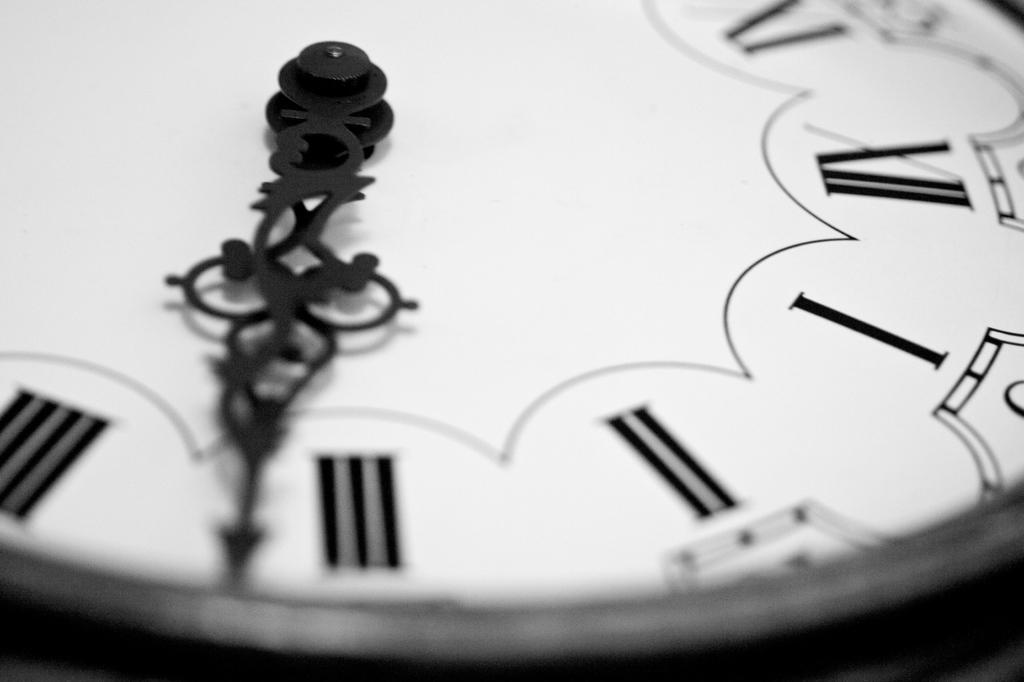What is the color scheme of the image? The image is black and white. What object can be seen in the image? There is a clock in the image. How many wings can be seen on the clock in the image? There are no wings present on the clock in the image. What type of mice are interacting with the clock in the image? There are no mice present in the image. 